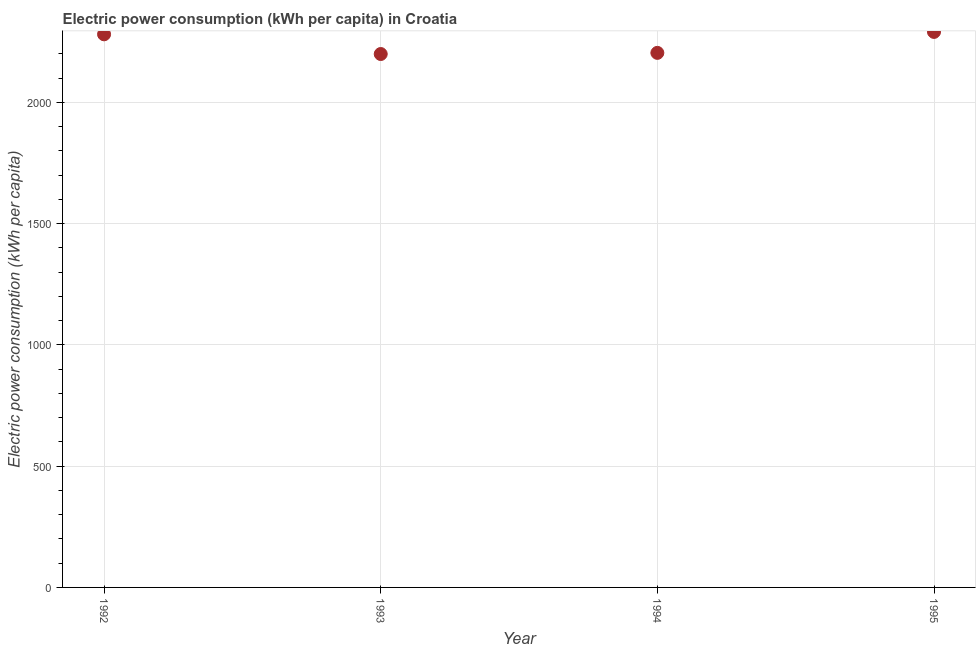What is the electric power consumption in 1995?
Provide a short and direct response. 2290.43. Across all years, what is the maximum electric power consumption?
Give a very brief answer. 2290.43. Across all years, what is the minimum electric power consumption?
Offer a terse response. 2199.35. In which year was the electric power consumption maximum?
Make the answer very short. 1995. What is the sum of the electric power consumption?
Provide a succinct answer. 8974.4. What is the difference between the electric power consumption in 1992 and 1993?
Ensure brevity in your answer.  81.18. What is the average electric power consumption per year?
Offer a terse response. 2243.6. What is the median electric power consumption?
Offer a very short reply. 2242.31. Do a majority of the years between 1993 and 1995 (inclusive) have electric power consumption greater than 1300 kWh per capita?
Provide a short and direct response. Yes. What is the ratio of the electric power consumption in 1992 to that in 1994?
Ensure brevity in your answer.  1.03. Is the electric power consumption in 1992 less than that in 1993?
Keep it short and to the point. No. What is the difference between the highest and the second highest electric power consumption?
Make the answer very short. 9.89. Is the sum of the electric power consumption in 1992 and 1995 greater than the maximum electric power consumption across all years?
Your answer should be very brief. Yes. What is the difference between the highest and the lowest electric power consumption?
Provide a short and direct response. 91.07. Does the electric power consumption monotonically increase over the years?
Provide a short and direct response. No. Are the values on the major ticks of Y-axis written in scientific E-notation?
Offer a very short reply. No. What is the title of the graph?
Ensure brevity in your answer.  Electric power consumption (kWh per capita) in Croatia. What is the label or title of the Y-axis?
Give a very brief answer. Electric power consumption (kWh per capita). What is the Electric power consumption (kWh per capita) in 1992?
Your answer should be very brief. 2280.54. What is the Electric power consumption (kWh per capita) in 1993?
Make the answer very short. 2199.35. What is the Electric power consumption (kWh per capita) in 1994?
Provide a short and direct response. 2204.09. What is the Electric power consumption (kWh per capita) in 1995?
Give a very brief answer. 2290.43. What is the difference between the Electric power consumption (kWh per capita) in 1992 and 1993?
Provide a succinct answer. 81.18. What is the difference between the Electric power consumption (kWh per capita) in 1992 and 1994?
Offer a terse response. 76.45. What is the difference between the Electric power consumption (kWh per capita) in 1992 and 1995?
Offer a terse response. -9.89. What is the difference between the Electric power consumption (kWh per capita) in 1993 and 1994?
Provide a succinct answer. -4.73. What is the difference between the Electric power consumption (kWh per capita) in 1993 and 1995?
Make the answer very short. -91.07. What is the difference between the Electric power consumption (kWh per capita) in 1994 and 1995?
Keep it short and to the point. -86.34. What is the ratio of the Electric power consumption (kWh per capita) in 1992 to that in 1994?
Make the answer very short. 1.03. What is the ratio of the Electric power consumption (kWh per capita) in 1993 to that in 1994?
Offer a terse response. 1. 